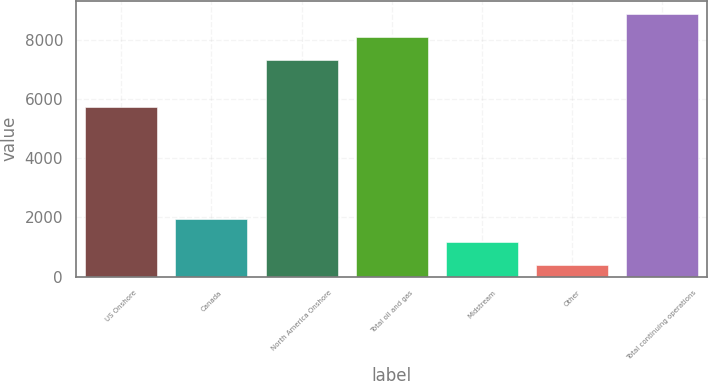Convert chart to OTSL. <chart><loc_0><loc_0><loc_500><loc_500><bar_chart><fcel>US Onshore<fcel>Canada<fcel>North America Onshore<fcel>Total oil and gas<fcel>Midstream<fcel>Other<fcel>Total continuing operations<nl><fcel>5719<fcel>1961.8<fcel>7325<fcel>8107.9<fcel>1178.9<fcel>396<fcel>8890.8<nl></chart> 